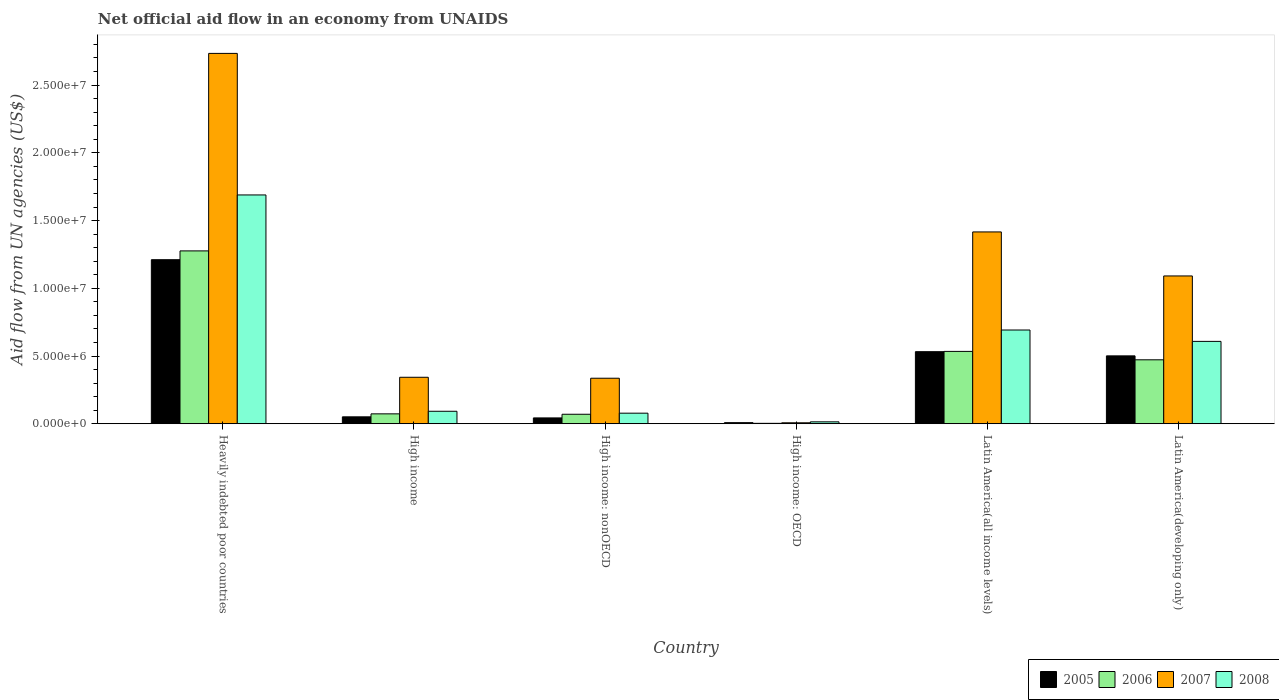How many groups of bars are there?
Your answer should be very brief. 6. Are the number of bars on each tick of the X-axis equal?
Provide a short and direct response. Yes. How many bars are there on the 2nd tick from the left?
Offer a very short reply. 4. How many bars are there on the 3rd tick from the right?
Your answer should be very brief. 4. What is the net official aid flow in 2005 in High income: nonOECD?
Your response must be concise. 4.30e+05. Across all countries, what is the maximum net official aid flow in 2006?
Your response must be concise. 1.28e+07. Across all countries, what is the minimum net official aid flow in 2005?
Give a very brief answer. 8.00e+04. In which country was the net official aid flow in 2008 maximum?
Your answer should be very brief. Heavily indebted poor countries. In which country was the net official aid flow in 2006 minimum?
Offer a very short reply. High income: OECD. What is the total net official aid flow in 2006 in the graph?
Offer a very short reply. 2.43e+07. What is the difference between the net official aid flow in 2006 in High income and that in Latin America(developing only)?
Provide a succinct answer. -3.99e+06. What is the difference between the net official aid flow in 2006 in Latin America(developing only) and the net official aid flow in 2005 in Latin America(all income levels)?
Your response must be concise. -6.00e+05. What is the average net official aid flow in 2008 per country?
Provide a succinct answer. 5.29e+06. What is the difference between the net official aid flow of/in 2007 and net official aid flow of/in 2008 in High income?
Your response must be concise. 2.51e+06. What is the ratio of the net official aid flow in 2007 in High income: OECD to that in High income: nonOECD?
Your answer should be compact. 0.02. What is the difference between the highest and the second highest net official aid flow in 2008?
Your answer should be compact. 1.08e+07. What is the difference between the highest and the lowest net official aid flow in 2007?
Provide a succinct answer. 2.73e+07. In how many countries, is the net official aid flow in 2008 greater than the average net official aid flow in 2008 taken over all countries?
Make the answer very short. 3. Is the sum of the net official aid flow in 2006 in High income: OECD and Latin America(all income levels) greater than the maximum net official aid flow in 2007 across all countries?
Offer a terse response. No. What does the 2nd bar from the left in High income: nonOECD represents?
Provide a short and direct response. 2006. What does the 4th bar from the right in Heavily indebted poor countries represents?
Your answer should be very brief. 2005. Is it the case that in every country, the sum of the net official aid flow in 2007 and net official aid flow in 2006 is greater than the net official aid flow in 2008?
Provide a succinct answer. No. How many bars are there?
Offer a terse response. 24. Does the graph contain grids?
Provide a succinct answer. No. What is the title of the graph?
Make the answer very short. Net official aid flow in an economy from UNAIDS. What is the label or title of the Y-axis?
Your answer should be very brief. Aid flow from UN agencies (US$). What is the Aid flow from UN agencies (US$) in 2005 in Heavily indebted poor countries?
Offer a terse response. 1.21e+07. What is the Aid flow from UN agencies (US$) in 2006 in Heavily indebted poor countries?
Give a very brief answer. 1.28e+07. What is the Aid flow from UN agencies (US$) of 2007 in Heavily indebted poor countries?
Provide a short and direct response. 2.73e+07. What is the Aid flow from UN agencies (US$) in 2008 in Heavily indebted poor countries?
Provide a short and direct response. 1.69e+07. What is the Aid flow from UN agencies (US$) of 2005 in High income?
Keep it short and to the point. 5.10e+05. What is the Aid flow from UN agencies (US$) in 2006 in High income?
Your answer should be very brief. 7.30e+05. What is the Aid flow from UN agencies (US$) in 2007 in High income?
Keep it short and to the point. 3.43e+06. What is the Aid flow from UN agencies (US$) in 2008 in High income?
Provide a succinct answer. 9.20e+05. What is the Aid flow from UN agencies (US$) in 2005 in High income: nonOECD?
Offer a terse response. 4.30e+05. What is the Aid flow from UN agencies (US$) in 2007 in High income: nonOECD?
Your answer should be compact. 3.36e+06. What is the Aid flow from UN agencies (US$) of 2008 in High income: nonOECD?
Provide a short and direct response. 7.80e+05. What is the Aid flow from UN agencies (US$) of 2006 in High income: OECD?
Provide a short and direct response. 3.00e+04. What is the Aid flow from UN agencies (US$) in 2005 in Latin America(all income levels)?
Keep it short and to the point. 5.32e+06. What is the Aid flow from UN agencies (US$) of 2006 in Latin America(all income levels)?
Ensure brevity in your answer.  5.34e+06. What is the Aid flow from UN agencies (US$) of 2007 in Latin America(all income levels)?
Offer a terse response. 1.42e+07. What is the Aid flow from UN agencies (US$) in 2008 in Latin America(all income levels)?
Offer a very short reply. 6.92e+06. What is the Aid flow from UN agencies (US$) in 2005 in Latin America(developing only)?
Provide a succinct answer. 5.01e+06. What is the Aid flow from UN agencies (US$) of 2006 in Latin America(developing only)?
Offer a very short reply. 4.72e+06. What is the Aid flow from UN agencies (US$) of 2007 in Latin America(developing only)?
Provide a short and direct response. 1.09e+07. What is the Aid flow from UN agencies (US$) in 2008 in Latin America(developing only)?
Provide a short and direct response. 6.08e+06. Across all countries, what is the maximum Aid flow from UN agencies (US$) of 2005?
Your response must be concise. 1.21e+07. Across all countries, what is the maximum Aid flow from UN agencies (US$) of 2006?
Keep it short and to the point. 1.28e+07. Across all countries, what is the maximum Aid flow from UN agencies (US$) in 2007?
Make the answer very short. 2.73e+07. Across all countries, what is the maximum Aid flow from UN agencies (US$) of 2008?
Your answer should be very brief. 1.69e+07. Across all countries, what is the minimum Aid flow from UN agencies (US$) in 2006?
Keep it short and to the point. 3.00e+04. Across all countries, what is the minimum Aid flow from UN agencies (US$) of 2007?
Your answer should be compact. 7.00e+04. What is the total Aid flow from UN agencies (US$) in 2005 in the graph?
Offer a very short reply. 2.35e+07. What is the total Aid flow from UN agencies (US$) of 2006 in the graph?
Your response must be concise. 2.43e+07. What is the total Aid flow from UN agencies (US$) in 2007 in the graph?
Offer a terse response. 5.93e+07. What is the total Aid flow from UN agencies (US$) of 2008 in the graph?
Give a very brief answer. 3.17e+07. What is the difference between the Aid flow from UN agencies (US$) in 2005 in Heavily indebted poor countries and that in High income?
Your response must be concise. 1.16e+07. What is the difference between the Aid flow from UN agencies (US$) of 2006 in Heavily indebted poor countries and that in High income?
Your response must be concise. 1.20e+07. What is the difference between the Aid flow from UN agencies (US$) of 2007 in Heavily indebted poor countries and that in High income?
Your answer should be compact. 2.39e+07. What is the difference between the Aid flow from UN agencies (US$) of 2008 in Heavily indebted poor countries and that in High income?
Make the answer very short. 1.60e+07. What is the difference between the Aid flow from UN agencies (US$) of 2005 in Heavily indebted poor countries and that in High income: nonOECD?
Your answer should be very brief. 1.17e+07. What is the difference between the Aid flow from UN agencies (US$) in 2006 in Heavily indebted poor countries and that in High income: nonOECD?
Offer a very short reply. 1.21e+07. What is the difference between the Aid flow from UN agencies (US$) of 2007 in Heavily indebted poor countries and that in High income: nonOECD?
Your answer should be compact. 2.40e+07. What is the difference between the Aid flow from UN agencies (US$) of 2008 in Heavily indebted poor countries and that in High income: nonOECD?
Your answer should be very brief. 1.61e+07. What is the difference between the Aid flow from UN agencies (US$) in 2005 in Heavily indebted poor countries and that in High income: OECD?
Your response must be concise. 1.20e+07. What is the difference between the Aid flow from UN agencies (US$) in 2006 in Heavily indebted poor countries and that in High income: OECD?
Keep it short and to the point. 1.27e+07. What is the difference between the Aid flow from UN agencies (US$) of 2007 in Heavily indebted poor countries and that in High income: OECD?
Give a very brief answer. 2.73e+07. What is the difference between the Aid flow from UN agencies (US$) in 2008 in Heavily indebted poor countries and that in High income: OECD?
Make the answer very short. 1.68e+07. What is the difference between the Aid flow from UN agencies (US$) of 2005 in Heavily indebted poor countries and that in Latin America(all income levels)?
Provide a short and direct response. 6.79e+06. What is the difference between the Aid flow from UN agencies (US$) in 2006 in Heavily indebted poor countries and that in Latin America(all income levels)?
Your answer should be very brief. 7.42e+06. What is the difference between the Aid flow from UN agencies (US$) of 2007 in Heavily indebted poor countries and that in Latin America(all income levels)?
Offer a terse response. 1.32e+07. What is the difference between the Aid flow from UN agencies (US$) in 2008 in Heavily indebted poor countries and that in Latin America(all income levels)?
Your answer should be compact. 9.97e+06. What is the difference between the Aid flow from UN agencies (US$) in 2005 in Heavily indebted poor countries and that in Latin America(developing only)?
Ensure brevity in your answer.  7.10e+06. What is the difference between the Aid flow from UN agencies (US$) of 2006 in Heavily indebted poor countries and that in Latin America(developing only)?
Give a very brief answer. 8.04e+06. What is the difference between the Aid flow from UN agencies (US$) of 2007 in Heavily indebted poor countries and that in Latin America(developing only)?
Offer a very short reply. 1.64e+07. What is the difference between the Aid flow from UN agencies (US$) of 2008 in Heavily indebted poor countries and that in Latin America(developing only)?
Your answer should be compact. 1.08e+07. What is the difference between the Aid flow from UN agencies (US$) in 2006 in High income and that in High income: nonOECD?
Your answer should be very brief. 3.00e+04. What is the difference between the Aid flow from UN agencies (US$) in 2007 in High income and that in High income: nonOECD?
Your answer should be very brief. 7.00e+04. What is the difference between the Aid flow from UN agencies (US$) of 2006 in High income and that in High income: OECD?
Keep it short and to the point. 7.00e+05. What is the difference between the Aid flow from UN agencies (US$) of 2007 in High income and that in High income: OECD?
Give a very brief answer. 3.36e+06. What is the difference between the Aid flow from UN agencies (US$) in 2008 in High income and that in High income: OECD?
Ensure brevity in your answer.  7.80e+05. What is the difference between the Aid flow from UN agencies (US$) in 2005 in High income and that in Latin America(all income levels)?
Provide a short and direct response. -4.81e+06. What is the difference between the Aid flow from UN agencies (US$) of 2006 in High income and that in Latin America(all income levels)?
Keep it short and to the point. -4.61e+06. What is the difference between the Aid flow from UN agencies (US$) of 2007 in High income and that in Latin America(all income levels)?
Offer a very short reply. -1.07e+07. What is the difference between the Aid flow from UN agencies (US$) of 2008 in High income and that in Latin America(all income levels)?
Provide a short and direct response. -6.00e+06. What is the difference between the Aid flow from UN agencies (US$) in 2005 in High income and that in Latin America(developing only)?
Keep it short and to the point. -4.50e+06. What is the difference between the Aid flow from UN agencies (US$) in 2006 in High income and that in Latin America(developing only)?
Ensure brevity in your answer.  -3.99e+06. What is the difference between the Aid flow from UN agencies (US$) of 2007 in High income and that in Latin America(developing only)?
Your response must be concise. -7.48e+06. What is the difference between the Aid flow from UN agencies (US$) in 2008 in High income and that in Latin America(developing only)?
Your answer should be very brief. -5.16e+06. What is the difference between the Aid flow from UN agencies (US$) of 2005 in High income: nonOECD and that in High income: OECD?
Provide a short and direct response. 3.50e+05. What is the difference between the Aid flow from UN agencies (US$) of 2006 in High income: nonOECD and that in High income: OECD?
Offer a terse response. 6.70e+05. What is the difference between the Aid flow from UN agencies (US$) of 2007 in High income: nonOECD and that in High income: OECD?
Give a very brief answer. 3.29e+06. What is the difference between the Aid flow from UN agencies (US$) of 2008 in High income: nonOECD and that in High income: OECD?
Your answer should be very brief. 6.40e+05. What is the difference between the Aid flow from UN agencies (US$) of 2005 in High income: nonOECD and that in Latin America(all income levels)?
Your answer should be very brief. -4.89e+06. What is the difference between the Aid flow from UN agencies (US$) in 2006 in High income: nonOECD and that in Latin America(all income levels)?
Your answer should be compact. -4.64e+06. What is the difference between the Aid flow from UN agencies (US$) of 2007 in High income: nonOECD and that in Latin America(all income levels)?
Provide a short and direct response. -1.08e+07. What is the difference between the Aid flow from UN agencies (US$) in 2008 in High income: nonOECD and that in Latin America(all income levels)?
Provide a short and direct response. -6.14e+06. What is the difference between the Aid flow from UN agencies (US$) in 2005 in High income: nonOECD and that in Latin America(developing only)?
Your answer should be compact. -4.58e+06. What is the difference between the Aid flow from UN agencies (US$) in 2006 in High income: nonOECD and that in Latin America(developing only)?
Keep it short and to the point. -4.02e+06. What is the difference between the Aid flow from UN agencies (US$) in 2007 in High income: nonOECD and that in Latin America(developing only)?
Make the answer very short. -7.55e+06. What is the difference between the Aid flow from UN agencies (US$) of 2008 in High income: nonOECD and that in Latin America(developing only)?
Provide a short and direct response. -5.30e+06. What is the difference between the Aid flow from UN agencies (US$) of 2005 in High income: OECD and that in Latin America(all income levels)?
Your answer should be very brief. -5.24e+06. What is the difference between the Aid flow from UN agencies (US$) of 2006 in High income: OECD and that in Latin America(all income levels)?
Your answer should be very brief. -5.31e+06. What is the difference between the Aid flow from UN agencies (US$) in 2007 in High income: OECD and that in Latin America(all income levels)?
Ensure brevity in your answer.  -1.41e+07. What is the difference between the Aid flow from UN agencies (US$) of 2008 in High income: OECD and that in Latin America(all income levels)?
Your answer should be very brief. -6.78e+06. What is the difference between the Aid flow from UN agencies (US$) of 2005 in High income: OECD and that in Latin America(developing only)?
Provide a succinct answer. -4.93e+06. What is the difference between the Aid flow from UN agencies (US$) in 2006 in High income: OECD and that in Latin America(developing only)?
Make the answer very short. -4.69e+06. What is the difference between the Aid flow from UN agencies (US$) in 2007 in High income: OECD and that in Latin America(developing only)?
Provide a short and direct response. -1.08e+07. What is the difference between the Aid flow from UN agencies (US$) of 2008 in High income: OECD and that in Latin America(developing only)?
Give a very brief answer. -5.94e+06. What is the difference between the Aid flow from UN agencies (US$) of 2006 in Latin America(all income levels) and that in Latin America(developing only)?
Your answer should be compact. 6.20e+05. What is the difference between the Aid flow from UN agencies (US$) in 2007 in Latin America(all income levels) and that in Latin America(developing only)?
Give a very brief answer. 3.25e+06. What is the difference between the Aid flow from UN agencies (US$) in 2008 in Latin America(all income levels) and that in Latin America(developing only)?
Your response must be concise. 8.40e+05. What is the difference between the Aid flow from UN agencies (US$) in 2005 in Heavily indebted poor countries and the Aid flow from UN agencies (US$) in 2006 in High income?
Ensure brevity in your answer.  1.14e+07. What is the difference between the Aid flow from UN agencies (US$) in 2005 in Heavily indebted poor countries and the Aid flow from UN agencies (US$) in 2007 in High income?
Give a very brief answer. 8.68e+06. What is the difference between the Aid flow from UN agencies (US$) in 2005 in Heavily indebted poor countries and the Aid flow from UN agencies (US$) in 2008 in High income?
Provide a succinct answer. 1.12e+07. What is the difference between the Aid flow from UN agencies (US$) of 2006 in Heavily indebted poor countries and the Aid flow from UN agencies (US$) of 2007 in High income?
Give a very brief answer. 9.33e+06. What is the difference between the Aid flow from UN agencies (US$) in 2006 in Heavily indebted poor countries and the Aid flow from UN agencies (US$) in 2008 in High income?
Your response must be concise. 1.18e+07. What is the difference between the Aid flow from UN agencies (US$) of 2007 in Heavily indebted poor countries and the Aid flow from UN agencies (US$) of 2008 in High income?
Ensure brevity in your answer.  2.64e+07. What is the difference between the Aid flow from UN agencies (US$) in 2005 in Heavily indebted poor countries and the Aid flow from UN agencies (US$) in 2006 in High income: nonOECD?
Provide a succinct answer. 1.14e+07. What is the difference between the Aid flow from UN agencies (US$) of 2005 in Heavily indebted poor countries and the Aid flow from UN agencies (US$) of 2007 in High income: nonOECD?
Your response must be concise. 8.75e+06. What is the difference between the Aid flow from UN agencies (US$) of 2005 in Heavily indebted poor countries and the Aid flow from UN agencies (US$) of 2008 in High income: nonOECD?
Provide a succinct answer. 1.13e+07. What is the difference between the Aid flow from UN agencies (US$) in 2006 in Heavily indebted poor countries and the Aid flow from UN agencies (US$) in 2007 in High income: nonOECD?
Provide a short and direct response. 9.40e+06. What is the difference between the Aid flow from UN agencies (US$) in 2006 in Heavily indebted poor countries and the Aid flow from UN agencies (US$) in 2008 in High income: nonOECD?
Offer a terse response. 1.20e+07. What is the difference between the Aid flow from UN agencies (US$) of 2007 in Heavily indebted poor countries and the Aid flow from UN agencies (US$) of 2008 in High income: nonOECD?
Provide a short and direct response. 2.66e+07. What is the difference between the Aid flow from UN agencies (US$) in 2005 in Heavily indebted poor countries and the Aid flow from UN agencies (US$) in 2006 in High income: OECD?
Keep it short and to the point. 1.21e+07. What is the difference between the Aid flow from UN agencies (US$) of 2005 in Heavily indebted poor countries and the Aid flow from UN agencies (US$) of 2007 in High income: OECD?
Provide a succinct answer. 1.20e+07. What is the difference between the Aid flow from UN agencies (US$) of 2005 in Heavily indebted poor countries and the Aid flow from UN agencies (US$) of 2008 in High income: OECD?
Your response must be concise. 1.20e+07. What is the difference between the Aid flow from UN agencies (US$) of 2006 in Heavily indebted poor countries and the Aid flow from UN agencies (US$) of 2007 in High income: OECD?
Offer a very short reply. 1.27e+07. What is the difference between the Aid flow from UN agencies (US$) in 2006 in Heavily indebted poor countries and the Aid flow from UN agencies (US$) in 2008 in High income: OECD?
Keep it short and to the point. 1.26e+07. What is the difference between the Aid flow from UN agencies (US$) of 2007 in Heavily indebted poor countries and the Aid flow from UN agencies (US$) of 2008 in High income: OECD?
Your response must be concise. 2.72e+07. What is the difference between the Aid flow from UN agencies (US$) of 2005 in Heavily indebted poor countries and the Aid flow from UN agencies (US$) of 2006 in Latin America(all income levels)?
Provide a short and direct response. 6.77e+06. What is the difference between the Aid flow from UN agencies (US$) of 2005 in Heavily indebted poor countries and the Aid flow from UN agencies (US$) of 2007 in Latin America(all income levels)?
Provide a short and direct response. -2.05e+06. What is the difference between the Aid flow from UN agencies (US$) of 2005 in Heavily indebted poor countries and the Aid flow from UN agencies (US$) of 2008 in Latin America(all income levels)?
Keep it short and to the point. 5.19e+06. What is the difference between the Aid flow from UN agencies (US$) in 2006 in Heavily indebted poor countries and the Aid flow from UN agencies (US$) in 2007 in Latin America(all income levels)?
Provide a succinct answer. -1.40e+06. What is the difference between the Aid flow from UN agencies (US$) of 2006 in Heavily indebted poor countries and the Aid flow from UN agencies (US$) of 2008 in Latin America(all income levels)?
Make the answer very short. 5.84e+06. What is the difference between the Aid flow from UN agencies (US$) of 2007 in Heavily indebted poor countries and the Aid flow from UN agencies (US$) of 2008 in Latin America(all income levels)?
Offer a terse response. 2.04e+07. What is the difference between the Aid flow from UN agencies (US$) in 2005 in Heavily indebted poor countries and the Aid flow from UN agencies (US$) in 2006 in Latin America(developing only)?
Provide a short and direct response. 7.39e+06. What is the difference between the Aid flow from UN agencies (US$) of 2005 in Heavily indebted poor countries and the Aid flow from UN agencies (US$) of 2007 in Latin America(developing only)?
Ensure brevity in your answer.  1.20e+06. What is the difference between the Aid flow from UN agencies (US$) in 2005 in Heavily indebted poor countries and the Aid flow from UN agencies (US$) in 2008 in Latin America(developing only)?
Your response must be concise. 6.03e+06. What is the difference between the Aid flow from UN agencies (US$) in 2006 in Heavily indebted poor countries and the Aid flow from UN agencies (US$) in 2007 in Latin America(developing only)?
Your answer should be very brief. 1.85e+06. What is the difference between the Aid flow from UN agencies (US$) of 2006 in Heavily indebted poor countries and the Aid flow from UN agencies (US$) of 2008 in Latin America(developing only)?
Provide a succinct answer. 6.68e+06. What is the difference between the Aid flow from UN agencies (US$) of 2007 in Heavily indebted poor countries and the Aid flow from UN agencies (US$) of 2008 in Latin America(developing only)?
Your response must be concise. 2.13e+07. What is the difference between the Aid flow from UN agencies (US$) of 2005 in High income and the Aid flow from UN agencies (US$) of 2006 in High income: nonOECD?
Keep it short and to the point. -1.90e+05. What is the difference between the Aid flow from UN agencies (US$) of 2005 in High income and the Aid flow from UN agencies (US$) of 2007 in High income: nonOECD?
Your response must be concise. -2.85e+06. What is the difference between the Aid flow from UN agencies (US$) in 2005 in High income and the Aid flow from UN agencies (US$) in 2008 in High income: nonOECD?
Provide a succinct answer. -2.70e+05. What is the difference between the Aid flow from UN agencies (US$) in 2006 in High income and the Aid flow from UN agencies (US$) in 2007 in High income: nonOECD?
Offer a terse response. -2.63e+06. What is the difference between the Aid flow from UN agencies (US$) in 2006 in High income and the Aid flow from UN agencies (US$) in 2008 in High income: nonOECD?
Your answer should be compact. -5.00e+04. What is the difference between the Aid flow from UN agencies (US$) in 2007 in High income and the Aid flow from UN agencies (US$) in 2008 in High income: nonOECD?
Give a very brief answer. 2.65e+06. What is the difference between the Aid flow from UN agencies (US$) in 2005 in High income and the Aid flow from UN agencies (US$) in 2006 in High income: OECD?
Offer a terse response. 4.80e+05. What is the difference between the Aid flow from UN agencies (US$) of 2005 in High income and the Aid flow from UN agencies (US$) of 2007 in High income: OECD?
Provide a succinct answer. 4.40e+05. What is the difference between the Aid flow from UN agencies (US$) of 2006 in High income and the Aid flow from UN agencies (US$) of 2008 in High income: OECD?
Offer a very short reply. 5.90e+05. What is the difference between the Aid flow from UN agencies (US$) in 2007 in High income and the Aid flow from UN agencies (US$) in 2008 in High income: OECD?
Provide a short and direct response. 3.29e+06. What is the difference between the Aid flow from UN agencies (US$) in 2005 in High income and the Aid flow from UN agencies (US$) in 2006 in Latin America(all income levels)?
Ensure brevity in your answer.  -4.83e+06. What is the difference between the Aid flow from UN agencies (US$) in 2005 in High income and the Aid flow from UN agencies (US$) in 2007 in Latin America(all income levels)?
Offer a terse response. -1.36e+07. What is the difference between the Aid flow from UN agencies (US$) in 2005 in High income and the Aid flow from UN agencies (US$) in 2008 in Latin America(all income levels)?
Provide a succinct answer. -6.41e+06. What is the difference between the Aid flow from UN agencies (US$) of 2006 in High income and the Aid flow from UN agencies (US$) of 2007 in Latin America(all income levels)?
Ensure brevity in your answer.  -1.34e+07. What is the difference between the Aid flow from UN agencies (US$) in 2006 in High income and the Aid flow from UN agencies (US$) in 2008 in Latin America(all income levels)?
Give a very brief answer. -6.19e+06. What is the difference between the Aid flow from UN agencies (US$) in 2007 in High income and the Aid flow from UN agencies (US$) in 2008 in Latin America(all income levels)?
Give a very brief answer. -3.49e+06. What is the difference between the Aid flow from UN agencies (US$) of 2005 in High income and the Aid flow from UN agencies (US$) of 2006 in Latin America(developing only)?
Give a very brief answer. -4.21e+06. What is the difference between the Aid flow from UN agencies (US$) in 2005 in High income and the Aid flow from UN agencies (US$) in 2007 in Latin America(developing only)?
Keep it short and to the point. -1.04e+07. What is the difference between the Aid flow from UN agencies (US$) in 2005 in High income and the Aid flow from UN agencies (US$) in 2008 in Latin America(developing only)?
Give a very brief answer. -5.57e+06. What is the difference between the Aid flow from UN agencies (US$) of 2006 in High income and the Aid flow from UN agencies (US$) of 2007 in Latin America(developing only)?
Offer a very short reply. -1.02e+07. What is the difference between the Aid flow from UN agencies (US$) in 2006 in High income and the Aid flow from UN agencies (US$) in 2008 in Latin America(developing only)?
Give a very brief answer. -5.35e+06. What is the difference between the Aid flow from UN agencies (US$) in 2007 in High income and the Aid flow from UN agencies (US$) in 2008 in Latin America(developing only)?
Offer a terse response. -2.65e+06. What is the difference between the Aid flow from UN agencies (US$) of 2005 in High income: nonOECD and the Aid flow from UN agencies (US$) of 2006 in High income: OECD?
Provide a short and direct response. 4.00e+05. What is the difference between the Aid flow from UN agencies (US$) of 2006 in High income: nonOECD and the Aid flow from UN agencies (US$) of 2007 in High income: OECD?
Provide a succinct answer. 6.30e+05. What is the difference between the Aid flow from UN agencies (US$) of 2006 in High income: nonOECD and the Aid flow from UN agencies (US$) of 2008 in High income: OECD?
Provide a short and direct response. 5.60e+05. What is the difference between the Aid flow from UN agencies (US$) of 2007 in High income: nonOECD and the Aid flow from UN agencies (US$) of 2008 in High income: OECD?
Your answer should be very brief. 3.22e+06. What is the difference between the Aid flow from UN agencies (US$) of 2005 in High income: nonOECD and the Aid flow from UN agencies (US$) of 2006 in Latin America(all income levels)?
Make the answer very short. -4.91e+06. What is the difference between the Aid flow from UN agencies (US$) in 2005 in High income: nonOECD and the Aid flow from UN agencies (US$) in 2007 in Latin America(all income levels)?
Keep it short and to the point. -1.37e+07. What is the difference between the Aid flow from UN agencies (US$) of 2005 in High income: nonOECD and the Aid flow from UN agencies (US$) of 2008 in Latin America(all income levels)?
Your answer should be very brief. -6.49e+06. What is the difference between the Aid flow from UN agencies (US$) in 2006 in High income: nonOECD and the Aid flow from UN agencies (US$) in 2007 in Latin America(all income levels)?
Provide a succinct answer. -1.35e+07. What is the difference between the Aid flow from UN agencies (US$) in 2006 in High income: nonOECD and the Aid flow from UN agencies (US$) in 2008 in Latin America(all income levels)?
Your answer should be very brief. -6.22e+06. What is the difference between the Aid flow from UN agencies (US$) in 2007 in High income: nonOECD and the Aid flow from UN agencies (US$) in 2008 in Latin America(all income levels)?
Offer a very short reply. -3.56e+06. What is the difference between the Aid flow from UN agencies (US$) of 2005 in High income: nonOECD and the Aid flow from UN agencies (US$) of 2006 in Latin America(developing only)?
Provide a succinct answer. -4.29e+06. What is the difference between the Aid flow from UN agencies (US$) in 2005 in High income: nonOECD and the Aid flow from UN agencies (US$) in 2007 in Latin America(developing only)?
Your answer should be compact. -1.05e+07. What is the difference between the Aid flow from UN agencies (US$) of 2005 in High income: nonOECD and the Aid flow from UN agencies (US$) of 2008 in Latin America(developing only)?
Ensure brevity in your answer.  -5.65e+06. What is the difference between the Aid flow from UN agencies (US$) in 2006 in High income: nonOECD and the Aid flow from UN agencies (US$) in 2007 in Latin America(developing only)?
Your response must be concise. -1.02e+07. What is the difference between the Aid flow from UN agencies (US$) of 2006 in High income: nonOECD and the Aid flow from UN agencies (US$) of 2008 in Latin America(developing only)?
Your answer should be very brief. -5.38e+06. What is the difference between the Aid flow from UN agencies (US$) of 2007 in High income: nonOECD and the Aid flow from UN agencies (US$) of 2008 in Latin America(developing only)?
Your answer should be very brief. -2.72e+06. What is the difference between the Aid flow from UN agencies (US$) in 2005 in High income: OECD and the Aid flow from UN agencies (US$) in 2006 in Latin America(all income levels)?
Your answer should be compact. -5.26e+06. What is the difference between the Aid flow from UN agencies (US$) in 2005 in High income: OECD and the Aid flow from UN agencies (US$) in 2007 in Latin America(all income levels)?
Your answer should be compact. -1.41e+07. What is the difference between the Aid flow from UN agencies (US$) in 2005 in High income: OECD and the Aid flow from UN agencies (US$) in 2008 in Latin America(all income levels)?
Keep it short and to the point. -6.84e+06. What is the difference between the Aid flow from UN agencies (US$) of 2006 in High income: OECD and the Aid flow from UN agencies (US$) of 2007 in Latin America(all income levels)?
Offer a very short reply. -1.41e+07. What is the difference between the Aid flow from UN agencies (US$) of 2006 in High income: OECD and the Aid flow from UN agencies (US$) of 2008 in Latin America(all income levels)?
Your response must be concise. -6.89e+06. What is the difference between the Aid flow from UN agencies (US$) of 2007 in High income: OECD and the Aid flow from UN agencies (US$) of 2008 in Latin America(all income levels)?
Provide a short and direct response. -6.85e+06. What is the difference between the Aid flow from UN agencies (US$) of 2005 in High income: OECD and the Aid flow from UN agencies (US$) of 2006 in Latin America(developing only)?
Offer a terse response. -4.64e+06. What is the difference between the Aid flow from UN agencies (US$) of 2005 in High income: OECD and the Aid flow from UN agencies (US$) of 2007 in Latin America(developing only)?
Your response must be concise. -1.08e+07. What is the difference between the Aid flow from UN agencies (US$) in 2005 in High income: OECD and the Aid flow from UN agencies (US$) in 2008 in Latin America(developing only)?
Your answer should be compact. -6.00e+06. What is the difference between the Aid flow from UN agencies (US$) of 2006 in High income: OECD and the Aid flow from UN agencies (US$) of 2007 in Latin America(developing only)?
Offer a very short reply. -1.09e+07. What is the difference between the Aid flow from UN agencies (US$) of 2006 in High income: OECD and the Aid flow from UN agencies (US$) of 2008 in Latin America(developing only)?
Make the answer very short. -6.05e+06. What is the difference between the Aid flow from UN agencies (US$) of 2007 in High income: OECD and the Aid flow from UN agencies (US$) of 2008 in Latin America(developing only)?
Your answer should be very brief. -6.01e+06. What is the difference between the Aid flow from UN agencies (US$) in 2005 in Latin America(all income levels) and the Aid flow from UN agencies (US$) in 2006 in Latin America(developing only)?
Make the answer very short. 6.00e+05. What is the difference between the Aid flow from UN agencies (US$) of 2005 in Latin America(all income levels) and the Aid flow from UN agencies (US$) of 2007 in Latin America(developing only)?
Offer a terse response. -5.59e+06. What is the difference between the Aid flow from UN agencies (US$) of 2005 in Latin America(all income levels) and the Aid flow from UN agencies (US$) of 2008 in Latin America(developing only)?
Your answer should be very brief. -7.60e+05. What is the difference between the Aid flow from UN agencies (US$) in 2006 in Latin America(all income levels) and the Aid flow from UN agencies (US$) in 2007 in Latin America(developing only)?
Give a very brief answer. -5.57e+06. What is the difference between the Aid flow from UN agencies (US$) in 2006 in Latin America(all income levels) and the Aid flow from UN agencies (US$) in 2008 in Latin America(developing only)?
Provide a short and direct response. -7.40e+05. What is the difference between the Aid flow from UN agencies (US$) of 2007 in Latin America(all income levels) and the Aid flow from UN agencies (US$) of 2008 in Latin America(developing only)?
Your response must be concise. 8.08e+06. What is the average Aid flow from UN agencies (US$) in 2005 per country?
Offer a terse response. 3.91e+06. What is the average Aid flow from UN agencies (US$) in 2006 per country?
Your answer should be very brief. 4.05e+06. What is the average Aid flow from UN agencies (US$) of 2007 per country?
Give a very brief answer. 9.88e+06. What is the average Aid flow from UN agencies (US$) in 2008 per country?
Provide a short and direct response. 5.29e+06. What is the difference between the Aid flow from UN agencies (US$) in 2005 and Aid flow from UN agencies (US$) in 2006 in Heavily indebted poor countries?
Keep it short and to the point. -6.50e+05. What is the difference between the Aid flow from UN agencies (US$) of 2005 and Aid flow from UN agencies (US$) of 2007 in Heavily indebted poor countries?
Your answer should be very brief. -1.52e+07. What is the difference between the Aid flow from UN agencies (US$) in 2005 and Aid flow from UN agencies (US$) in 2008 in Heavily indebted poor countries?
Make the answer very short. -4.78e+06. What is the difference between the Aid flow from UN agencies (US$) of 2006 and Aid flow from UN agencies (US$) of 2007 in Heavily indebted poor countries?
Give a very brief answer. -1.46e+07. What is the difference between the Aid flow from UN agencies (US$) in 2006 and Aid flow from UN agencies (US$) in 2008 in Heavily indebted poor countries?
Ensure brevity in your answer.  -4.13e+06. What is the difference between the Aid flow from UN agencies (US$) in 2007 and Aid flow from UN agencies (US$) in 2008 in Heavily indebted poor countries?
Your answer should be very brief. 1.04e+07. What is the difference between the Aid flow from UN agencies (US$) in 2005 and Aid flow from UN agencies (US$) in 2007 in High income?
Your answer should be very brief. -2.92e+06. What is the difference between the Aid flow from UN agencies (US$) of 2005 and Aid flow from UN agencies (US$) of 2008 in High income?
Provide a short and direct response. -4.10e+05. What is the difference between the Aid flow from UN agencies (US$) in 2006 and Aid flow from UN agencies (US$) in 2007 in High income?
Make the answer very short. -2.70e+06. What is the difference between the Aid flow from UN agencies (US$) of 2006 and Aid flow from UN agencies (US$) of 2008 in High income?
Your answer should be very brief. -1.90e+05. What is the difference between the Aid flow from UN agencies (US$) of 2007 and Aid flow from UN agencies (US$) of 2008 in High income?
Your answer should be compact. 2.51e+06. What is the difference between the Aid flow from UN agencies (US$) of 2005 and Aid flow from UN agencies (US$) of 2006 in High income: nonOECD?
Keep it short and to the point. -2.70e+05. What is the difference between the Aid flow from UN agencies (US$) in 2005 and Aid flow from UN agencies (US$) in 2007 in High income: nonOECD?
Give a very brief answer. -2.93e+06. What is the difference between the Aid flow from UN agencies (US$) in 2005 and Aid flow from UN agencies (US$) in 2008 in High income: nonOECD?
Give a very brief answer. -3.50e+05. What is the difference between the Aid flow from UN agencies (US$) of 2006 and Aid flow from UN agencies (US$) of 2007 in High income: nonOECD?
Offer a terse response. -2.66e+06. What is the difference between the Aid flow from UN agencies (US$) in 2007 and Aid flow from UN agencies (US$) in 2008 in High income: nonOECD?
Your answer should be very brief. 2.58e+06. What is the difference between the Aid flow from UN agencies (US$) in 2007 and Aid flow from UN agencies (US$) in 2008 in High income: OECD?
Your answer should be compact. -7.00e+04. What is the difference between the Aid flow from UN agencies (US$) in 2005 and Aid flow from UN agencies (US$) in 2006 in Latin America(all income levels)?
Provide a short and direct response. -2.00e+04. What is the difference between the Aid flow from UN agencies (US$) of 2005 and Aid flow from UN agencies (US$) of 2007 in Latin America(all income levels)?
Keep it short and to the point. -8.84e+06. What is the difference between the Aid flow from UN agencies (US$) in 2005 and Aid flow from UN agencies (US$) in 2008 in Latin America(all income levels)?
Your answer should be compact. -1.60e+06. What is the difference between the Aid flow from UN agencies (US$) in 2006 and Aid flow from UN agencies (US$) in 2007 in Latin America(all income levels)?
Make the answer very short. -8.82e+06. What is the difference between the Aid flow from UN agencies (US$) of 2006 and Aid flow from UN agencies (US$) of 2008 in Latin America(all income levels)?
Make the answer very short. -1.58e+06. What is the difference between the Aid flow from UN agencies (US$) of 2007 and Aid flow from UN agencies (US$) of 2008 in Latin America(all income levels)?
Give a very brief answer. 7.24e+06. What is the difference between the Aid flow from UN agencies (US$) in 2005 and Aid flow from UN agencies (US$) in 2006 in Latin America(developing only)?
Make the answer very short. 2.90e+05. What is the difference between the Aid flow from UN agencies (US$) of 2005 and Aid flow from UN agencies (US$) of 2007 in Latin America(developing only)?
Offer a very short reply. -5.90e+06. What is the difference between the Aid flow from UN agencies (US$) of 2005 and Aid flow from UN agencies (US$) of 2008 in Latin America(developing only)?
Offer a terse response. -1.07e+06. What is the difference between the Aid flow from UN agencies (US$) in 2006 and Aid flow from UN agencies (US$) in 2007 in Latin America(developing only)?
Ensure brevity in your answer.  -6.19e+06. What is the difference between the Aid flow from UN agencies (US$) in 2006 and Aid flow from UN agencies (US$) in 2008 in Latin America(developing only)?
Ensure brevity in your answer.  -1.36e+06. What is the difference between the Aid flow from UN agencies (US$) of 2007 and Aid flow from UN agencies (US$) of 2008 in Latin America(developing only)?
Ensure brevity in your answer.  4.83e+06. What is the ratio of the Aid flow from UN agencies (US$) in 2005 in Heavily indebted poor countries to that in High income?
Provide a short and direct response. 23.75. What is the ratio of the Aid flow from UN agencies (US$) of 2006 in Heavily indebted poor countries to that in High income?
Your answer should be compact. 17.48. What is the ratio of the Aid flow from UN agencies (US$) of 2007 in Heavily indebted poor countries to that in High income?
Provide a succinct answer. 7.97. What is the ratio of the Aid flow from UN agencies (US$) in 2008 in Heavily indebted poor countries to that in High income?
Provide a short and direct response. 18.36. What is the ratio of the Aid flow from UN agencies (US$) of 2005 in Heavily indebted poor countries to that in High income: nonOECD?
Offer a terse response. 28.16. What is the ratio of the Aid flow from UN agencies (US$) in 2006 in Heavily indebted poor countries to that in High income: nonOECD?
Provide a short and direct response. 18.23. What is the ratio of the Aid flow from UN agencies (US$) in 2007 in Heavily indebted poor countries to that in High income: nonOECD?
Give a very brief answer. 8.14. What is the ratio of the Aid flow from UN agencies (US$) of 2008 in Heavily indebted poor countries to that in High income: nonOECD?
Make the answer very short. 21.65. What is the ratio of the Aid flow from UN agencies (US$) of 2005 in Heavily indebted poor countries to that in High income: OECD?
Make the answer very short. 151.38. What is the ratio of the Aid flow from UN agencies (US$) of 2006 in Heavily indebted poor countries to that in High income: OECD?
Provide a short and direct response. 425.33. What is the ratio of the Aid flow from UN agencies (US$) of 2007 in Heavily indebted poor countries to that in High income: OECD?
Provide a succinct answer. 390.57. What is the ratio of the Aid flow from UN agencies (US$) of 2008 in Heavily indebted poor countries to that in High income: OECD?
Offer a terse response. 120.64. What is the ratio of the Aid flow from UN agencies (US$) in 2005 in Heavily indebted poor countries to that in Latin America(all income levels)?
Your answer should be very brief. 2.28. What is the ratio of the Aid flow from UN agencies (US$) in 2006 in Heavily indebted poor countries to that in Latin America(all income levels)?
Your answer should be very brief. 2.39. What is the ratio of the Aid flow from UN agencies (US$) in 2007 in Heavily indebted poor countries to that in Latin America(all income levels)?
Provide a short and direct response. 1.93. What is the ratio of the Aid flow from UN agencies (US$) in 2008 in Heavily indebted poor countries to that in Latin America(all income levels)?
Your answer should be compact. 2.44. What is the ratio of the Aid flow from UN agencies (US$) in 2005 in Heavily indebted poor countries to that in Latin America(developing only)?
Your answer should be compact. 2.42. What is the ratio of the Aid flow from UN agencies (US$) in 2006 in Heavily indebted poor countries to that in Latin America(developing only)?
Ensure brevity in your answer.  2.7. What is the ratio of the Aid flow from UN agencies (US$) of 2007 in Heavily indebted poor countries to that in Latin America(developing only)?
Your response must be concise. 2.51. What is the ratio of the Aid flow from UN agencies (US$) of 2008 in Heavily indebted poor countries to that in Latin America(developing only)?
Make the answer very short. 2.78. What is the ratio of the Aid flow from UN agencies (US$) of 2005 in High income to that in High income: nonOECD?
Provide a short and direct response. 1.19. What is the ratio of the Aid flow from UN agencies (US$) in 2006 in High income to that in High income: nonOECD?
Your answer should be compact. 1.04. What is the ratio of the Aid flow from UN agencies (US$) in 2007 in High income to that in High income: nonOECD?
Provide a short and direct response. 1.02. What is the ratio of the Aid flow from UN agencies (US$) in 2008 in High income to that in High income: nonOECD?
Offer a very short reply. 1.18. What is the ratio of the Aid flow from UN agencies (US$) of 2005 in High income to that in High income: OECD?
Offer a terse response. 6.38. What is the ratio of the Aid flow from UN agencies (US$) of 2006 in High income to that in High income: OECD?
Offer a terse response. 24.33. What is the ratio of the Aid flow from UN agencies (US$) of 2008 in High income to that in High income: OECD?
Provide a succinct answer. 6.57. What is the ratio of the Aid flow from UN agencies (US$) of 2005 in High income to that in Latin America(all income levels)?
Offer a very short reply. 0.1. What is the ratio of the Aid flow from UN agencies (US$) in 2006 in High income to that in Latin America(all income levels)?
Your answer should be compact. 0.14. What is the ratio of the Aid flow from UN agencies (US$) of 2007 in High income to that in Latin America(all income levels)?
Keep it short and to the point. 0.24. What is the ratio of the Aid flow from UN agencies (US$) in 2008 in High income to that in Latin America(all income levels)?
Your response must be concise. 0.13. What is the ratio of the Aid flow from UN agencies (US$) of 2005 in High income to that in Latin America(developing only)?
Your answer should be very brief. 0.1. What is the ratio of the Aid flow from UN agencies (US$) in 2006 in High income to that in Latin America(developing only)?
Offer a terse response. 0.15. What is the ratio of the Aid flow from UN agencies (US$) of 2007 in High income to that in Latin America(developing only)?
Provide a succinct answer. 0.31. What is the ratio of the Aid flow from UN agencies (US$) in 2008 in High income to that in Latin America(developing only)?
Offer a very short reply. 0.15. What is the ratio of the Aid flow from UN agencies (US$) in 2005 in High income: nonOECD to that in High income: OECD?
Provide a short and direct response. 5.38. What is the ratio of the Aid flow from UN agencies (US$) of 2006 in High income: nonOECD to that in High income: OECD?
Provide a succinct answer. 23.33. What is the ratio of the Aid flow from UN agencies (US$) in 2007 in High income: nonOECD to that in High income: OECD?
Ensure brevity in your answer.  48. What is the ratio of the Aid flow from UN agencies (US$) of 2008 in High income: nonOECD to that in High income: OECD?
Your response must be concise. 5.57. What is the ratio of the Aid flow from UN agencies (US$) of 2005 in High income: nonOECD to that in Latin America(all income levels)?
Keep it short and to the point. 0.08. What is the ratio of the Aid flow from UN agencies (US$) of 2006 in High income: nonOECD to that in Latin America(all income levels)?
Give a very brief answer. 0.13. What is the ratio of the Aid flow from UN agencies (US$) in 2007 in High income: nonOECD to that in Latin America(all income levels)?
Make the answer very short. 0.24. What is the ratio of the Aid flow from UN agencies (US$) of 2008 in High income: nonOECD to that in Latin America(all income levels)?
Your response must be concise. 0.11. What is the ratio of the Aid flow from UN agencies (US$) of 2005 in High income: nonOECD to that in Latin America(developing only)?
Ensure brevity in your answer.  0.09. What is the ratio of the Aid flow from UN agencies (US$) in 2006 in High income: nonOECD to that in Latin America(developing only)?
Make the answer very short. 0.15. What is the ratio of the Aid flow from UN agencies (US$) in 2007 in High income: nonOECD to that in Latin America(developing only)?
Make the answer very short. 0.31. What is the ratio of the Aid flow from UN agencies (US$) of 2008 in High income: nonOECD to that in Latin America(developing only)?
Ensure brevity in your answer.  0.13. What is the ratio of the Aid flow from UN agencies (US$) of 2005 in High income: OECD to that in Latin America(all income levels)?
Provide a succinct answer. 0.01. What is the ratio of the Aid flow from UN agencies (US$) in 2006 in High income: OECD to that in Latin America(all income levels)?
Offer a very short reply. 0.01. What is the ratio of the Aid flow from UN agencies (US$) of 2007 in High income: OECD to that in Latin America(all income levels)?
Keep it short and to the point. 0. What is the ratio of the Aid flow from UN agencies (US$) in 2008 in High income: OECD to that in Latin America(all income levels)?
Ensure brevity in your answer.  0.02. What is the ratio of the Aid flow from UN agencies (US$) in 2005 in High income: OECD to that in Latin America(developing only)?
Your answer should be very brief. 0.02. What is the ratio of the Aid flow from UN agencies (US$) of 2006 in High income: OECD to that in Latin America(developing only)?
Provide a succinct answer. 0.01. What is the ratio of the Aid flow from UN agencies (US$) in 2007 in High income: OECD to that in Latin America(developing only)?
Give a very brief answer. 0.01. What is the ratio of the Aid flow from UN agencies (US$) in 2008 in High income: OECD to that in Latin America(developing only)?
Offer a terse response. 0.02. What is the ratio of the Aid flow from UN agencies (US$) of 2005 in Latin America(all income levels) to that in Latin America(developing only)?
Offer a very short reply. 1.06. What is the ratio of the Aid flow from UN agencies (US$) in 2006 in Latin America(all income levels) to that in Latin America(developing only)?
Ensure brevity in your answer.  1.13. What is the ratio of the Aid flow from UN agencies (US$) in 2007 in Latin America(all income levels) to that in Latin America(developing only)?
Ensure brevity in your answer.  1.3. What is the ratio of the Aid flow from UN agencies (US$) of 2008 in Latin America(all income levels) to that in Latin America(developing only)?
Offer a terse response. 1.14. What is the difference between the highest and the second highest Aid flow from UN agencies (US$) of 2005?
Your answer should be compact. 6.79e+06. What is the difference between the highest and the second highest Aid flow from UN agencies (US$) of 2006?
Provide a succinct answer. 7.42e+06. What is the difference between the highest and the second highest Aid flow from UN agencies (US$) in 2007?
Your answer should be very brief. 1.32e+07. What is the difference between the highest and the second highest Aid flow from UN agencies (US$) in 2008?
Ensure brevity in your answer.  9.97e+06. What is the difference between the highest and the lowest Aid flow from UN agencies (US$) of 2005?
Make the answer very short. 1.20e+07. What is the difference between the highest and the lowest Aid flow from UN agencies (US$) of 2006?
Provide a succinct answer. 1.27e+07. What is the difference between the highest and the lowest Aid flow from UN agencies (US$) in 2007?
Keep it short and to the point. 2.73e+07. What is the difference between the highest and the lowest Aid flow from UN agencies (US$) of 2008?
Provide a short and direct response. 1.68e+07. 